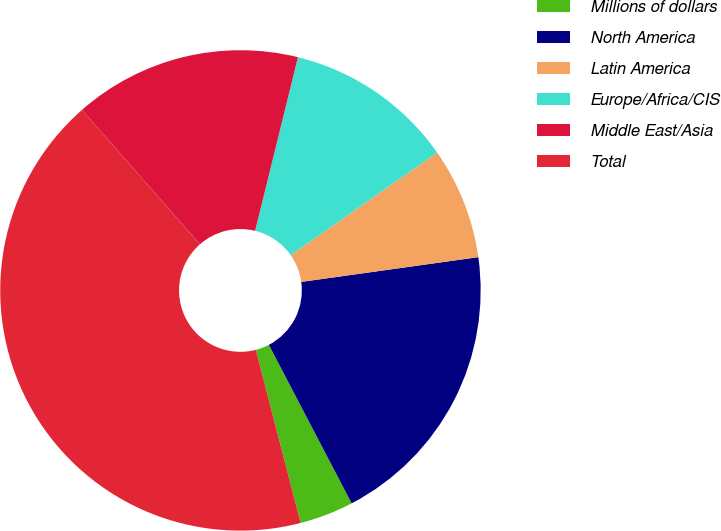Convert chart. <chart><loc_0><loc_0><loc_500><loc_500><pie_chart><fcel>Millions of dollars<fcel>North America<fcel>Latin America<fcel>Europe/Africa/CIS<fcel>Middle East/Asia<fcel>Total<nl><fcel>3.63%<fcel>19.55%<fcel>7.52%<fcel>11.42%<fcel>15.31%<fcel>42.57%<nl></chart> 